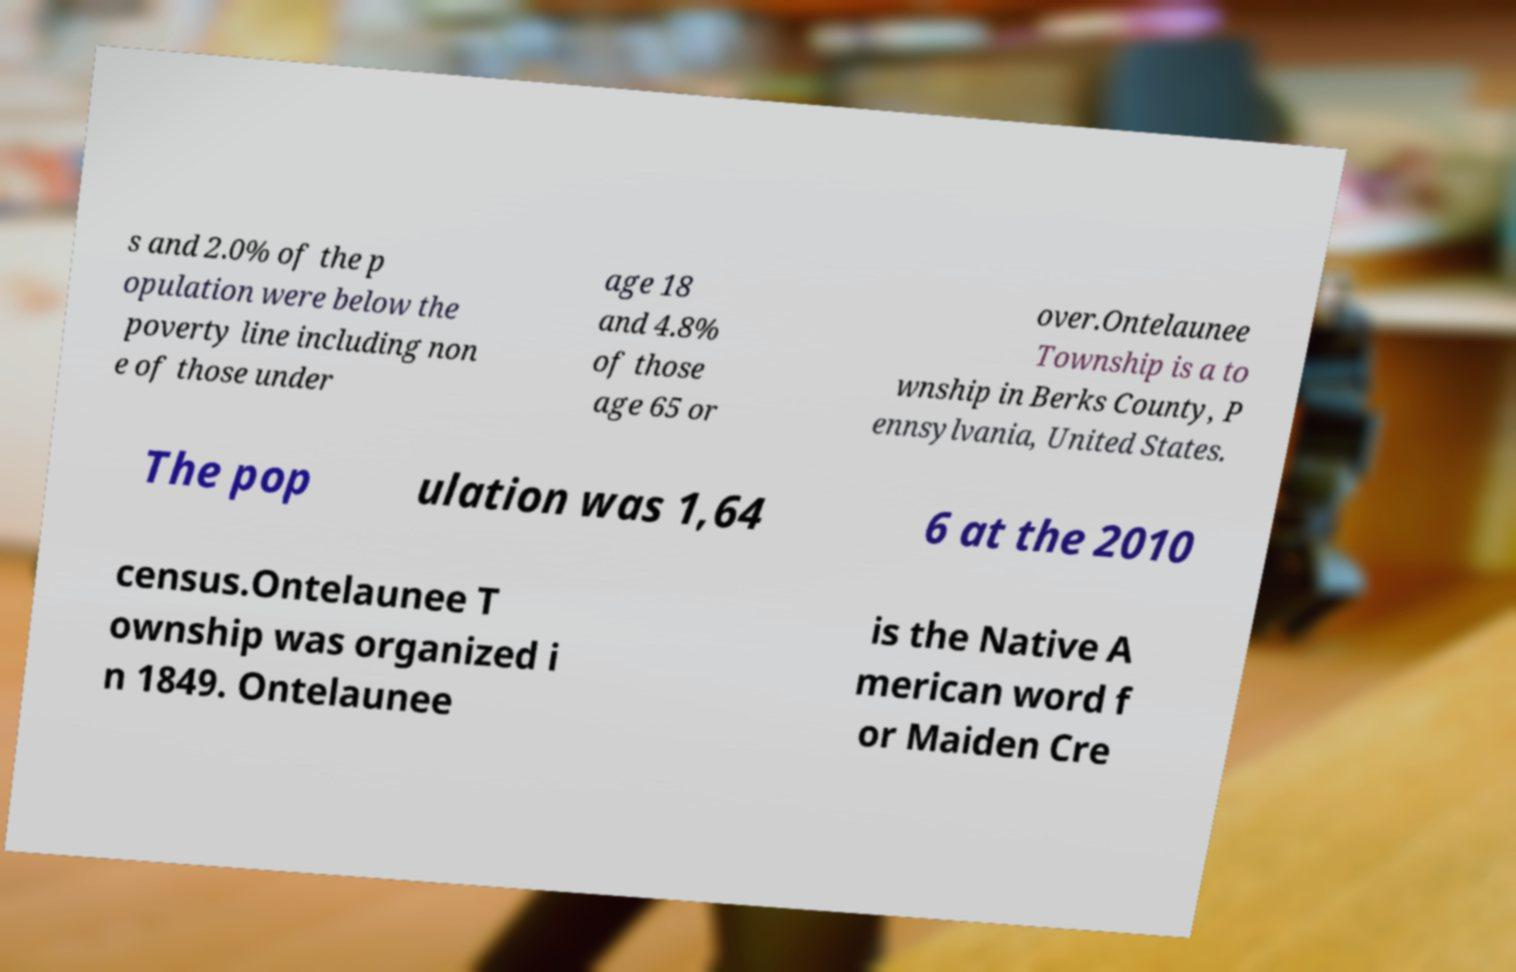Can you accurately transcribe the text from the provided image for me? s and 2.0% of the p opulation were below the poverty line including non e of those under age 18 and 4.8% of those age 65 or over.Ontelaunee Township is a to wnship in Berks County, P ennsylvania, United States. The pop ulation was 1,64 6 at the 2010 census.Ontelaunee T ownship was organized i n 1849. Ontelaunee is the Native A merican word f or Maiden Cre 